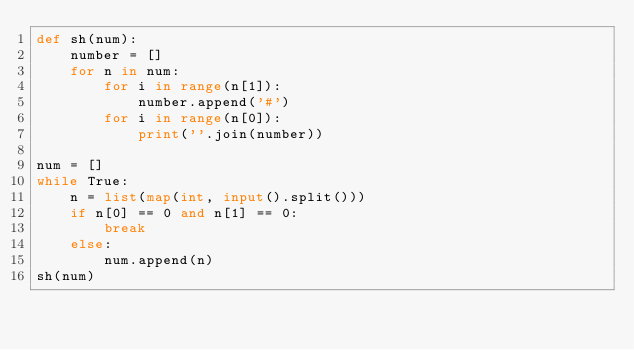<code> <loc_0><loc_0><loc_500><loc_500><_Python_>def sh(num):
    number = []
    for n in num:
        for i in range(n[1]):
            number.append('#')
        for i in range(n[0]):
            print(''.join(number))

num = []
while True:
    n = list(map(int, input().split()))
    if n[0] == 0 and n[1] == 0:
        break
    else:
        num.append(n)
sh(num)</code> 